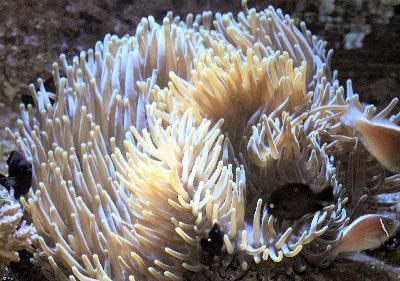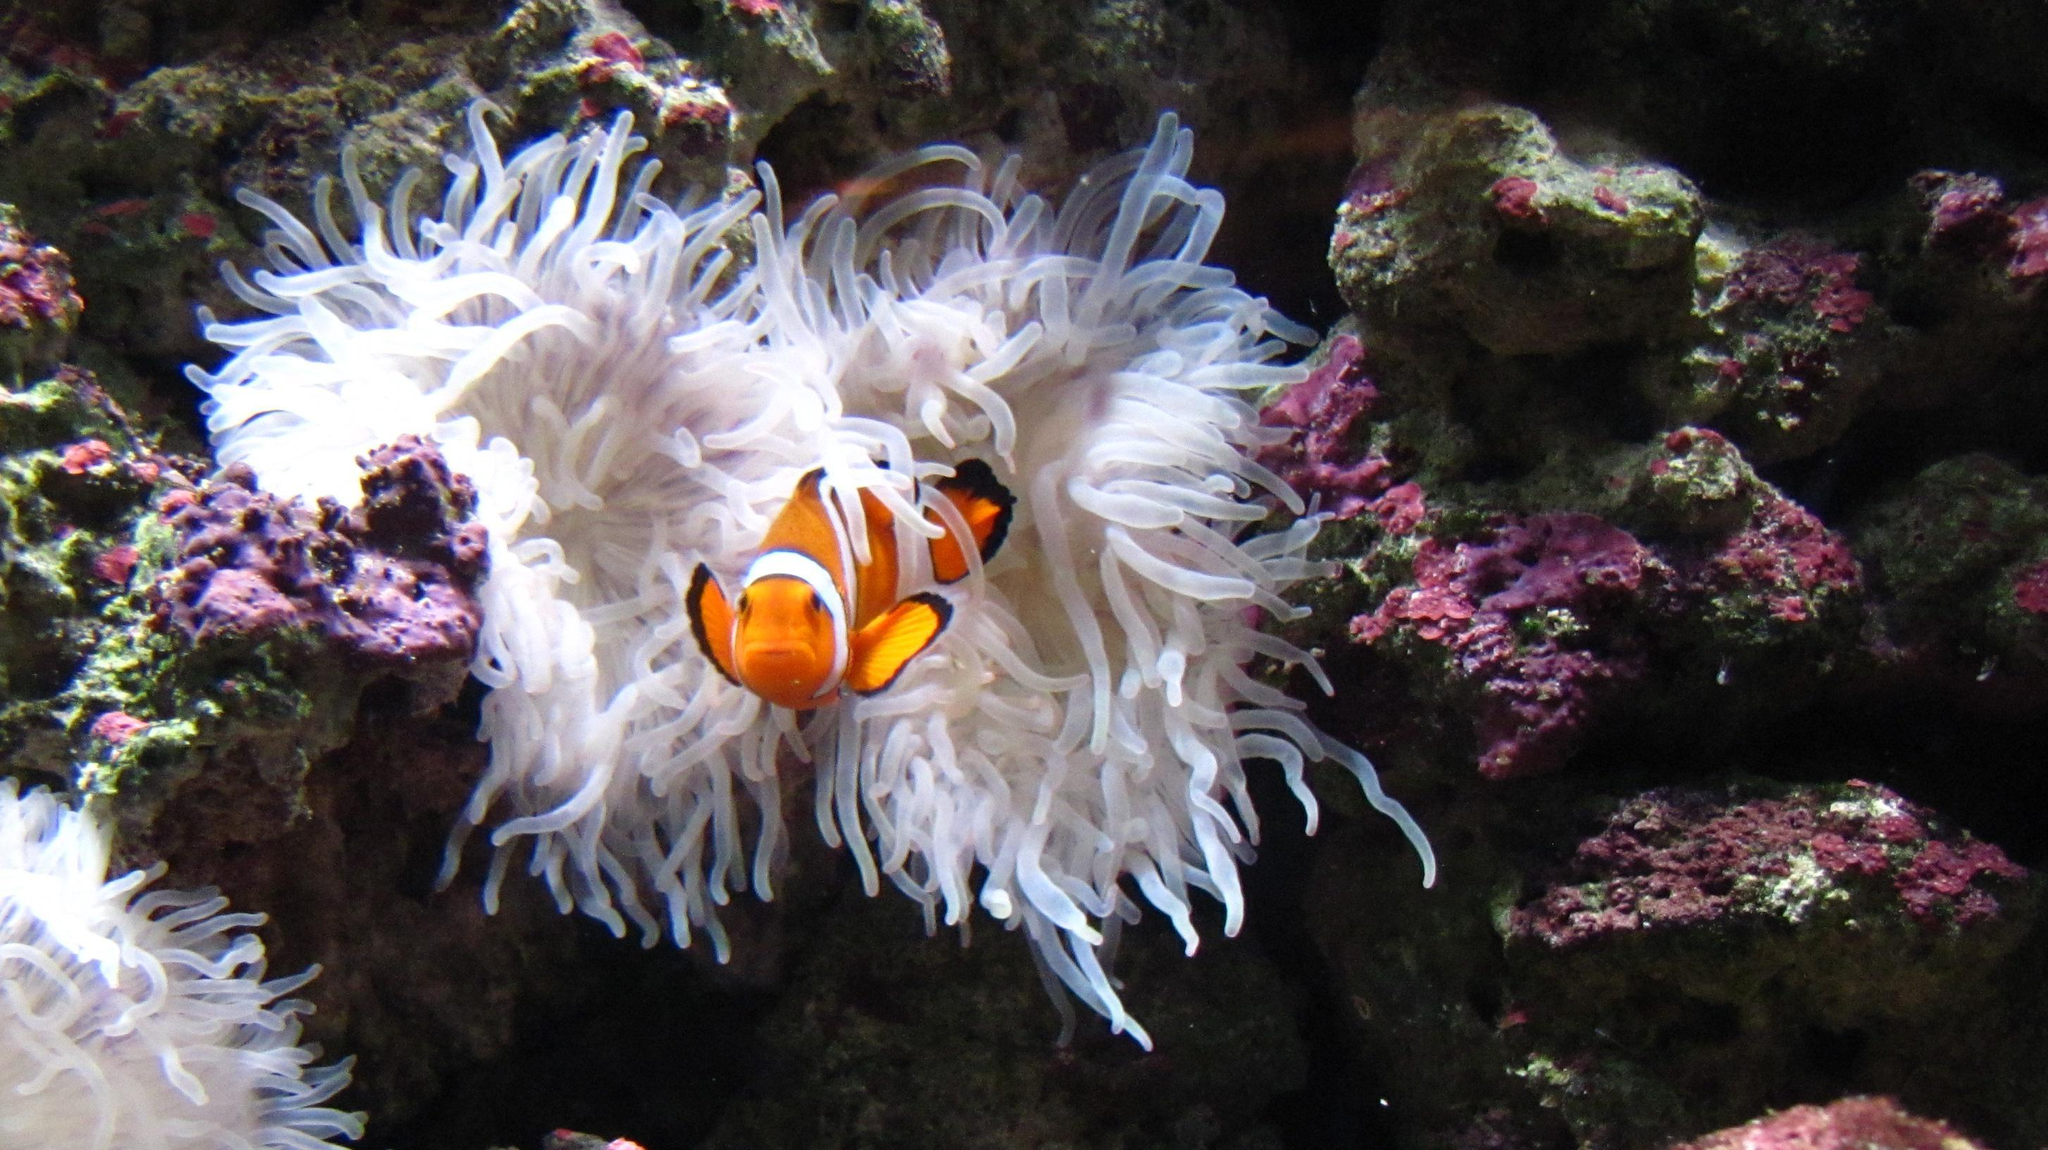The first image is the image on the left, the second image is the image on the right. Assess this claim about the two images: "Right and left images each show only one flower-shaped anemone with tendrils spreading out like petals, and the anemones do not share the same color.". Correct or not? Answer yes or no. No. 